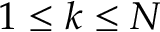<formula> <loc_0><loc_0><loc_500><loc_500>1 \leq k \leq N</formula> 